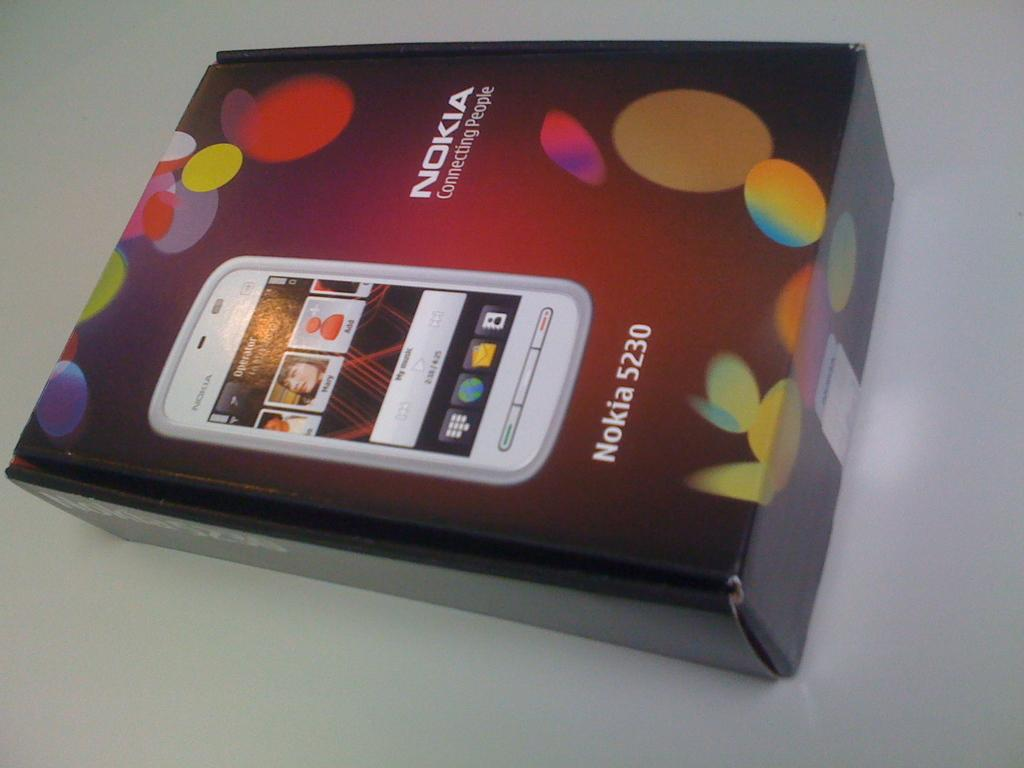What object is present on the table in the image? There is a box on the table in the image. Can you turn on the faucet to get water for the box in the image? There is no faucet present in the image, and the box does not require water. 